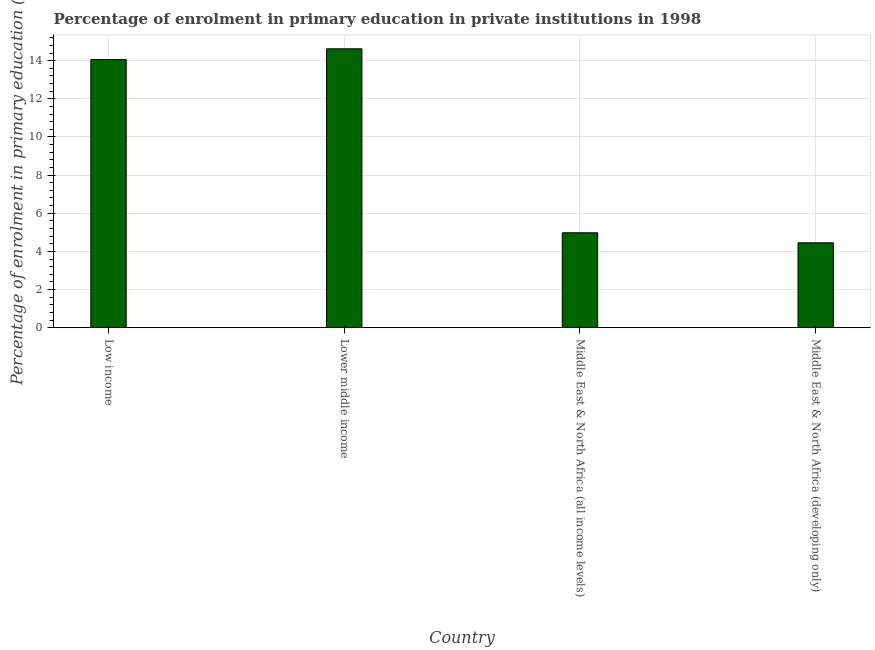Does the graph contain any zero values?
Offer a very short reply. No. Does the graph contain grids?
Provide a short and direct response. Yes. What is the title of the graph?
Keep it short and to the point. Percentage of enrolment in primary education in private institutions in 1998. What is the label or title of the Y-axis?
Ensure brevity in your answer.  Percentage of enrolment in primary education (%). What is the enrolment percentage in primary education in Low income?
Your answer should be compact. 14.06. Across all countries, what is the maximum enrolment percentage in primary education?
Provide a short and direct response. 14.62. Across all countries, what is the minimum enrolment percentage in primary education?
Your response must be concise. 4.45. In which country was the enrolment percentage in primary education maximum?
Provide a succinct answer. Lower middle income. In which country was the enrolment percentage in primary education minimum?
Make the answer very short. Middle East & North Africa (developing only). What is the sum of the enrolment percentage in primary education?
Provide a short and direct response. 38.1. What is the difference between the enrolment percentage in primary education in Low income and Middle East & North Africa (developing only)?
Ensure brevity in your answer.  9.61. What is the average enrolment percentage in primary education per country?
Provide a short and direct response. 9.53. What is the median enrolment percentage in primary education?
Your answer should be compact. 9.52. What is the ratio of the enrolment percentage in primary education in Lower middle income to that in Middle East & North Africa (developing only)?
Give a very brief answer. 3.29. Is the difference between the enrolment percentage in primary education in Low income and Middle East & North Africa (developing only) greater than the difference between any two countries?
Your answer should be compact. No. What is the difference between the highest and the second highest enrolment percentage in primary education?
Keep it short and to the point. 0.56. What is the difference between the highest and the lowest enrolment percentage in primary education?
Your response must be concise. 10.17. In how many countries, is the enrolment percentage in primary education greater than the average enrolment percentage in primary education taken over all countries?
Offer a terse response. 2. How many countries are there in the graph?
Provide a succinct answer. 4. What is the Percentage of enrolment in primary education (%) in Low income?
Your response must be concise. 14.06. What is the Percentage of enrolment in primary education (%) in Lower middle income?
Make the answer very short. 14.62. What is the Percentage of enrolment in primary education (%) in Middle East & North Africa (all income levels)?
Your answer should be compact. 4.98. What is the Percentage of enrolment in primary education (%) of Middle East & North Africa (developing only)?
Offer a very short reply. 4.45. What is the difference between the Percentage of enrolment in primary education (%) in Low income and Lower middle income?
Ensure brevity in your answer.  -0.56. What is the difference between the Percentage of enrolment in primary education (%) in Low income and Middle East & North Africa (all income levels)?
Give a very brief answer. 9.08. What is the difference between the Percentage of enrolment in primary education (%) in Low income and Middle East & North Africa (developing only)?
Provide a succinct answer. 9.61. What is the difference between the Percentage of enrolment in primary education (%) in Lower middle income and Middle East & North Africa (all income levels)?
Make the answer very short. 9.64. What is the difference between the Percentage of enrolment in primary education (%) in Lower middle income and Middle East & North Africa (developing only)?
Ensure brevity in your answer.  10.17. What is the difference between the Percentage of enrolment in primary education (%) in Middle East & North Africa (all income levels) and Middle East & North Africa (developing only)?
Your answer should be very brief. 0.53. What is the ratio of the Percentage of enrolment in primary education (%) in Low income to that in Lower middle income?
Give a very brief answer. 0.96. What is the ratio of the Percentage of enrolment in primary education (%) in Low income to that in Middle East & North Africa (all income levels)?
Your answer should be very brief. 2.83. What is the ratio of the Percentage of enrolment in primary education (%) in Low income to that in Middle East & North Africa (developing only)?
Give a very brief answer. 3.16. What is the ratio of the Percentage of enrolment in primary education (%) in Lower middle income to that in Middle East & North Africa (all income levels)?
Provide a succinct answer. 2.94. What is the ratio of the Percentage of enrolment in primary education (%) in Lower middle income to that in Middle East & North Africa (developing only)?
Your response must be concise. 3.29. What is the ratio of the Percentage of enrolment in primary education (%) in Middle East & North Africa (all income levels) to that in Middle East & North Africa (developing only)?
Ensure brevity in your answer.  1.12. 